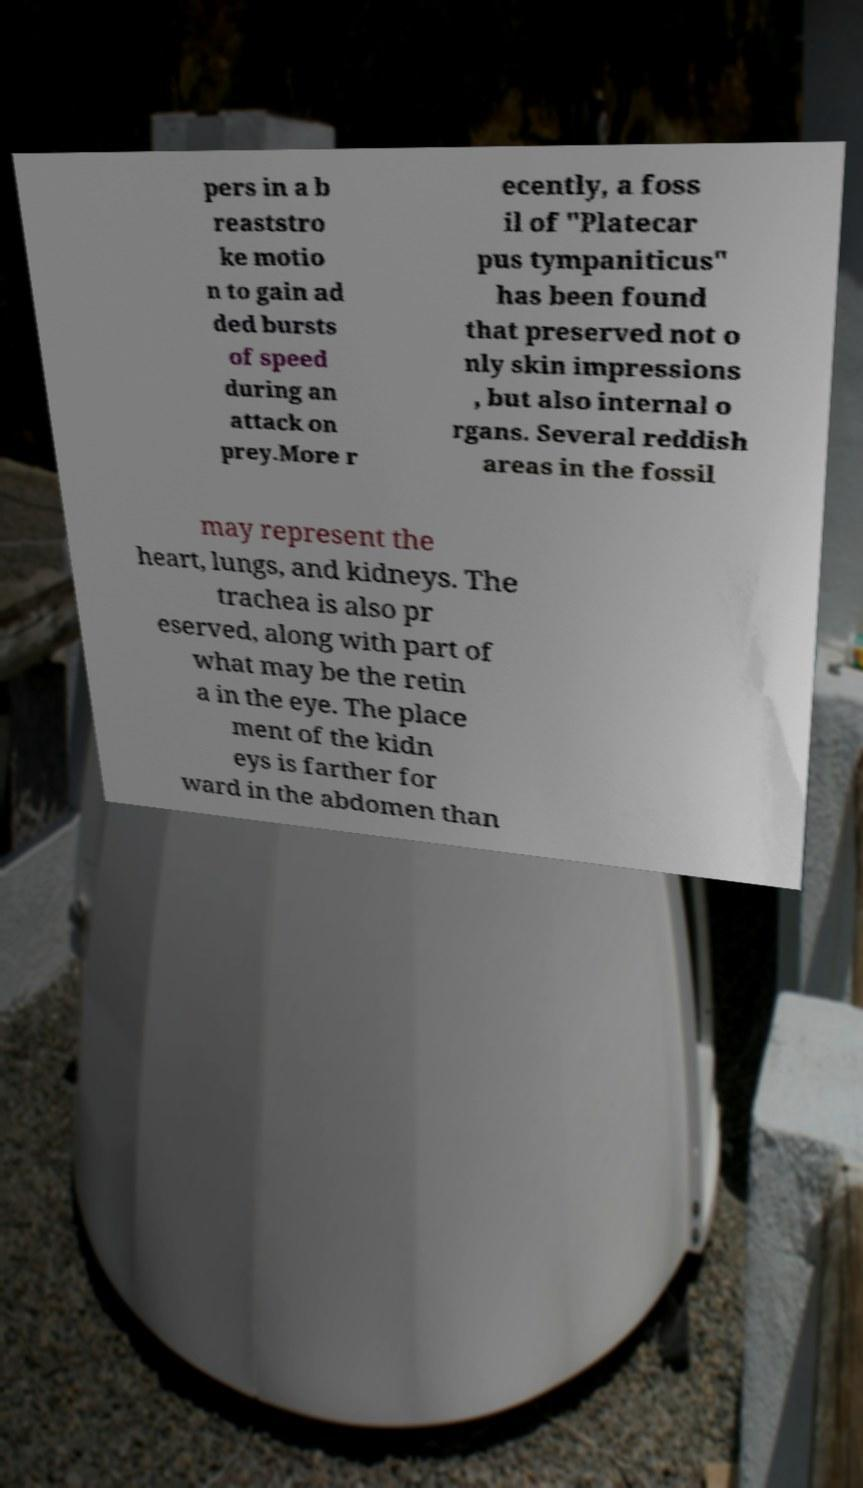Can you read and provide the text displayed in the image?This photo seems to have some interesting text. Can you extract and type it out for me? pers in a b reaststro ke motio n to gain ad ded bursts of speed during an attack on prey.More r ecently, a foss il of "Platecar pus tympaniticus" has been found that preserved not o nly skin impressions , but also internal o rgans. Several reddish areas in the fossil may represent the heart, lungs, and kidneys. The trachea is also pr eserved, along with part of what may be the retin a in the eye. The place ment of the kidn eys is farther for ward in the abdomen than 